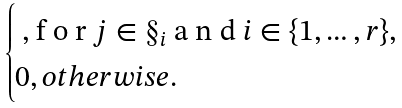<formula> <loc_0><loc_0><loc_500><loc_500>\begin{cases} $ , f o r $ j \in \S _ { i } $ a n d $ i \in \{ 1 , \dots , r \} , \\ 0 , o t h e r w i s e . \end{cases}</formula> 